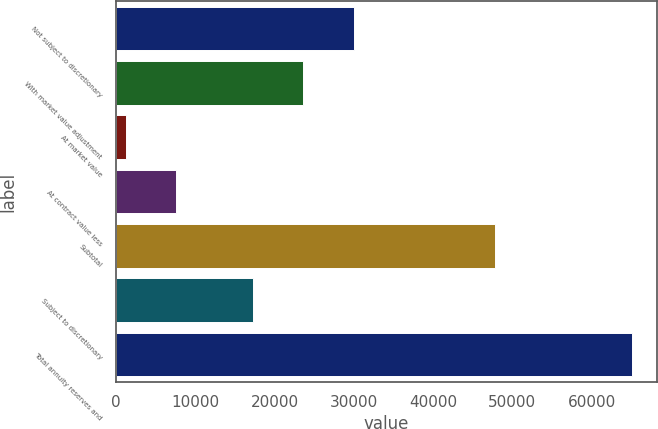<chart> <loc_0><loc_0><loc_500><loc_500><bar_chart><fcel>Not subject to discretionary<fcel>With market value adjustment<fcel>At market value<fcel>At contract value less<fcel>Subtotal<fcel>Subject to discretionary<fcel>Total annuity reserves and<nl><fcel>30032<fcel>23653<fcel>1235<fcel>7614<fcel>47751<fcel>17274<fcel>65025<nl></chart> 